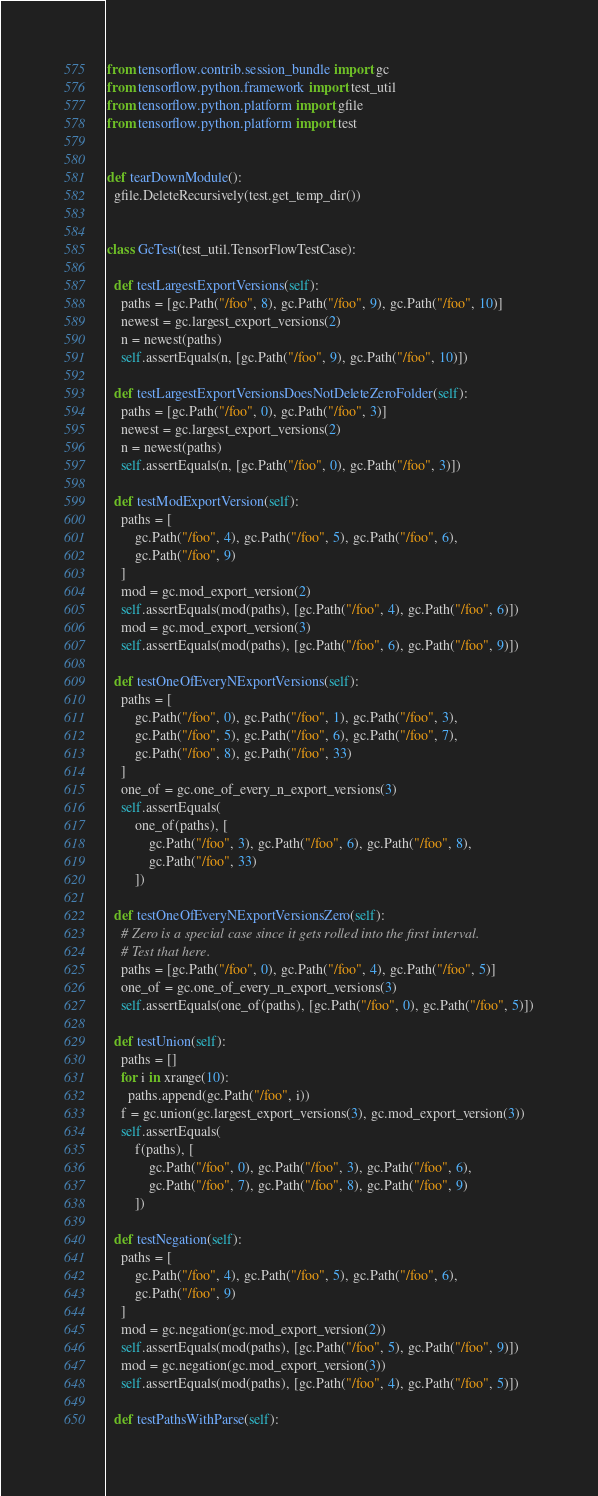<code> <loc_0><loc_0><loc_500><loc_500><_Python_>
from tensorflow.contrib.session_bundle import gc
from tensorflow.python.framework import test_util
from tensorflow.python.platform import gfile
from tensorflow.python.platform import test


def tearDownModule():
  gfile.DeleteRecursively(test.get_temp_dir())


class GcTest(test_util.TensorFlowTestCase):

  def testLargestExportVersions(self):
    paths = [gc.Path("/foo", 8), gc.Path("/foo", 9), gc.Path("/foo", 10)]
    newest = gc.largest_export_versions(2)
    n = newest(paths)
    self.assertEquals(n, [gc.Path("/foo", 9), gc.Path("/foo", 10)])

  def testLargestExportVersionsDoesNotDeleteZeroFolder(self):
    paths = [gc.Path("/foo", 0), gc.Path("/foo", 3)]
    newest = gc.largest_export_versions(2)
    n = newest(paths)
    self.assertEquals(n, [gc.Path("/foo", 0), gc.Path("/foo", 3)])

  def testModExportVersion(self):
    paths = [
        gc.Path("/foo", 4), gc.Path("/foo", 5), gc.Path("/foo", 6),
        gc.Path("/foo", 9)
    ]
    mod = gc.mod_export_version(2)
    self.assertEquals(mod(paths), [gc.Path("/foo", 4), gc.Path("/foo", 6)])
    mod = gc.mod_export_version(3)
    self.assertEquals(mod(paths), [gc.Path("/foo", 6), gc.Path("/foo", 9)])

  def testOneOfEveryNExportVersions(self):
    paths = [
        gc.Path("/foo", 0), gc.Path("/foo", 1), gc.Path("/foo", 3),
        gc.Path("/foo", 5), gc.Path("/foo", 6), gc.Path("/foo", 7),
        gc.Path("/foo", 8), gc.Path("/foo", 33)
    ]
    one_of = gc.one_of_every_n_export_versions(3)
    self.assertEquals(
        one_of(paths), [
            gc.Path("/foo", 3), gc.Path("/foo", 6), gc.Path("/foo", 8),
            gc.Path("/foo", 33)
        ])

  def testOneOfEveryNExportVersionsZero(self):
    # Zero is a special case since it gets rolled into the first interval.
    # Test that here.
    paths = [gc.Path("/foo", 0), gc.Path("/foo", 4), gc.Path("/foo", 5)]
    one_of = gc.one_of_every_n_export_versions(3)
    self.assertEquals(one_of(paths), [gc.Path("/foo", 0), gc.Path("/foo", 5)])

  def testUnion(self):
    paths = []
    for i in xrange(10):
      paths.append(gc.Path("/foo", i))
    f = gc.union(gc.largest_export_versions(3), gc.mod_export_version(3))
    self.assertEquals(
        f(paths), [
            gc.Path("/foo", 0), gc.Path("/foo", 3), gc.Path("/foo", 6),
            gc.Path("/foo", 7), gc.Path("/foo", 8), gc.Path("/foo", 9)
        ])

  def testNegation(self):
    paths = [
        gc.Path("/foo", 4), gc.Path("/foo", 5), gc.Path("/foo", 6),
        gc.Path("/foo", 9)
    ]
    mod = gc.negation(gc.mod_export_version(2))
    self.assertEquals(mod(paths), [gc.Path("/foo", 5), gc.Path("/foo", 9)])
    mod = gc.negation(gc.mod_export_version(3))
    self.assertEquals(mod(paths), [gc.Path("/foo", 4), gc.Path("/foo", 5)])

  def testPathsWithParse(self):</code> 